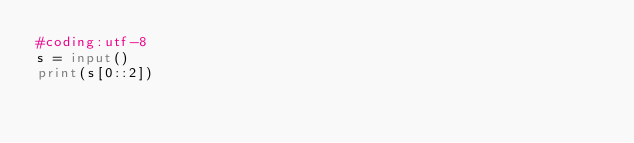<code> <loc_0><loc_0><loc_500><loc_500><_Python_>#coding:utf-8
s = input()
print(s[0::2])</code> 